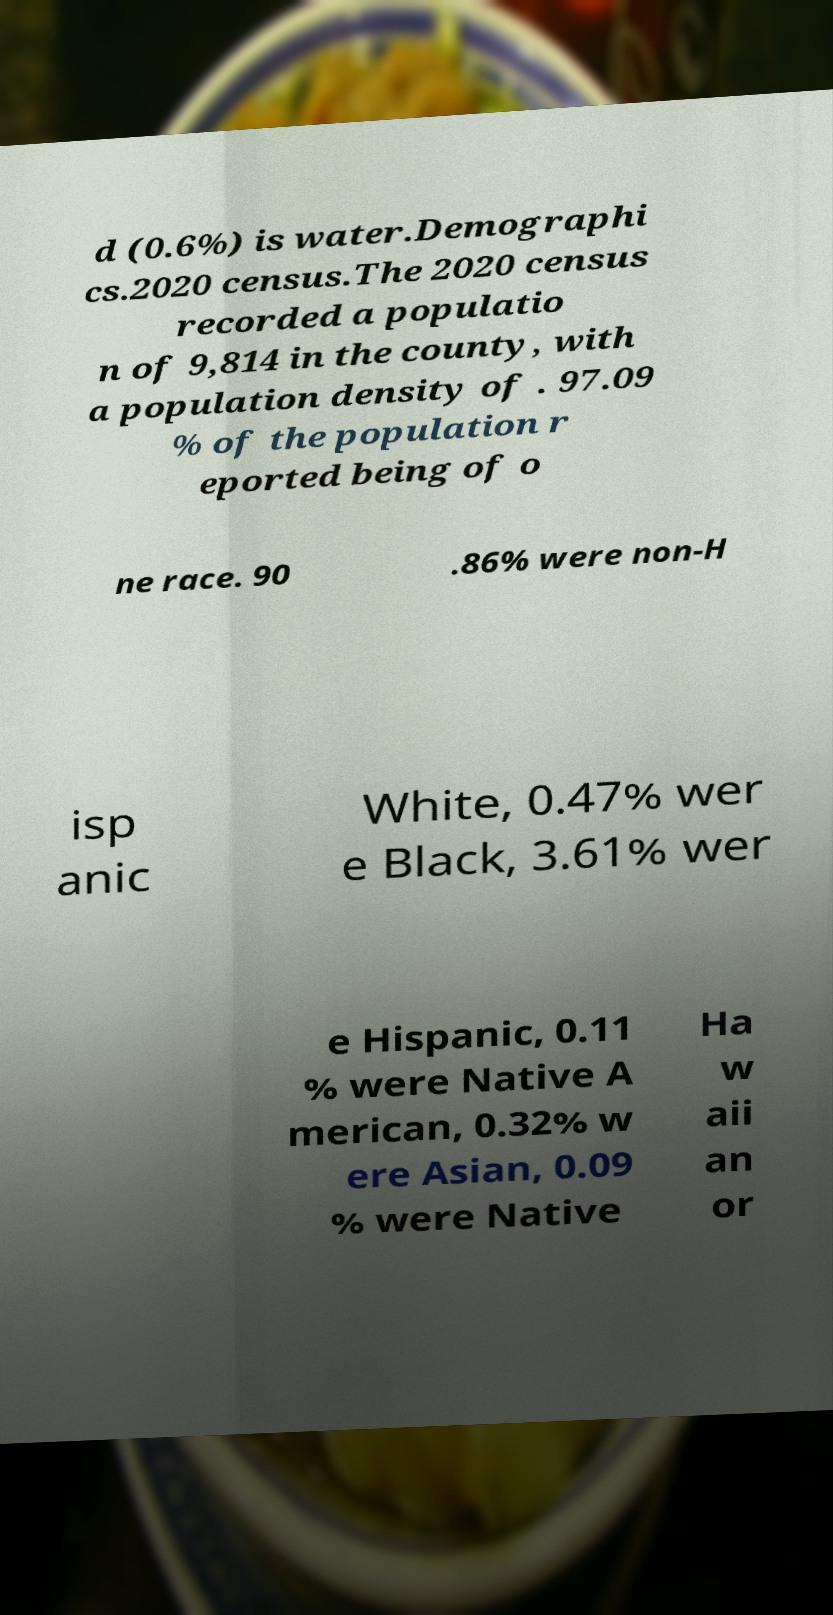Could you extract and type out the text from this image? d (0.6%) is water.Demographi cs.2020 census.The 2020 census recorded a populatio n of 9,814 in the county, with a population density of . 97.09 % of the population r eported being of o ne race. 90 .86% were non-H isp anic White, 0.47% wer e Black, 3.61% wer e Hispanic, 0.11 % were Native A merican, 0.32% w ere Asian, 0.09 % were Native Ha w aii an or 